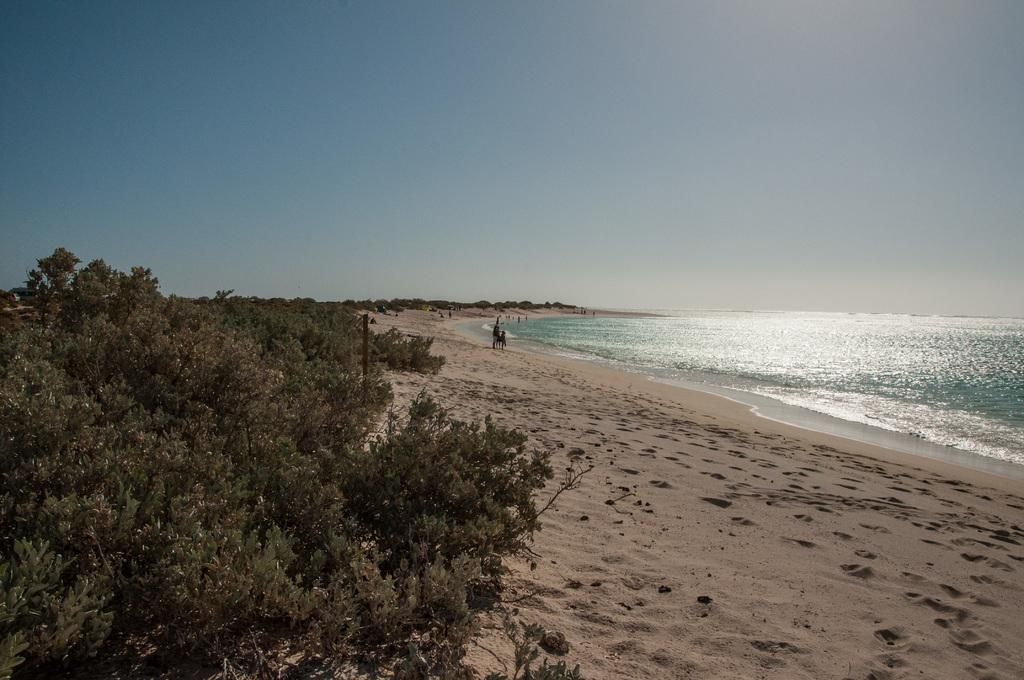What is the primary element visible in the image? There is water in the image. What can be seen near the water's edge? There are people on the shore in the image. What type of vegetation is visible in the image? There are trees visible in the image. What is the color of the sky in the image? The sky is blue in the image. What is the chance of finding an island in the water shown in the image? There is no island visible in the image, so it is impossible to determine the chance of finding one. 